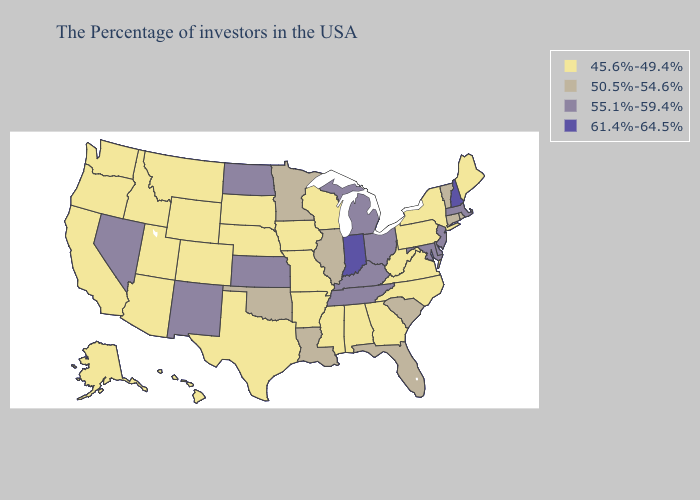Name the states that have a value in the range 50.5%-54.6%?
Keep it brief. Rhode Island, Vermont, Connecticut, South Carolina, Florida, Illinois, Louisiana, Minnesota, Oklahoma. Does Arkansas have the same value as South Carolina?
Concise answer only. No. What is the highest value in the South ?
Be succinct. 55.1%-59.4%. What is the value of Alaska?
Short answer required. 45.6%-49.4%. Name the states that have a value in the range 61.4%-64.5%?
Concise answer only. New Hampshire, Indiana. What is the highest value in the USA?
Quick response, please. 61.4%-64.5%. Among the states that border Missouri , which have the highest value?
Be succinct. Kentucky, Tennessee, Kansas. What is the value of Florida?
Be succinct. 50.5%-54.6%. Name the states that have a value in the range 55.1%-59.4%?
Short answer required. Massachusetts, New Jersey, Delaware, Maryland, Ohio, Michigan, Kentucky, Tennessee, Kansas, North Dakota, New Mexico, Nevada. Does Arkansas have the same value as Washington?
Short answer required. Yes. Does Wisconsin have the same value as Idaho?
Keep it brief. Yes. Does the map have missing data?
Concise answer only. No. What is the highest value in the USA?
Concise answer only. 61.4%-64.5%. Name the states that have a value in the range 50.5%-54.6%?
Answer briefly. Rhode Island, Vermont, Connecticut, South Carolina, Florida, Illinois, Louisiana, Minnesota, Oklahoma. What is the value of North Dakota?
Short answer required. 55.1%-59.4%. 